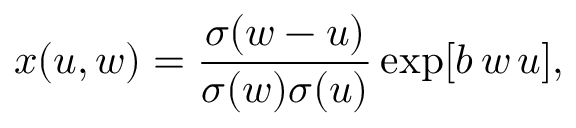<formula> <loc_0><loc_0><loc_500><loc_500>x ( u , w ) = { \frac { \sigma ( w - u ) } { \sigma ( w ) \sigma ( u ) } } \exp [ b \, w \, u ] ,</formula> 